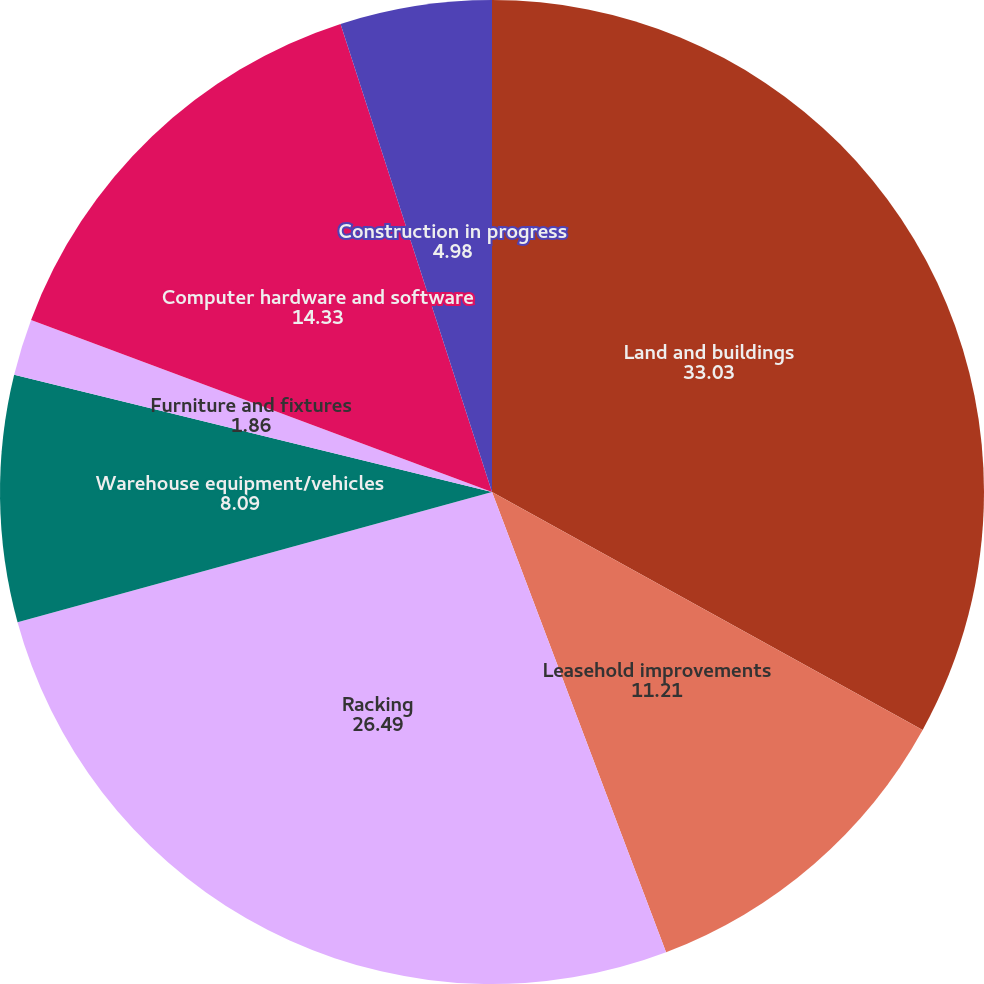Convert chart to OTSL. <chart><loc_0><loc_0><loc_500><loc_500><pie_chart><fcel>Land and buildings<fcel>Leasehold improvements<fcel>Racking<fcel>Warehouse equipment/vehicles<fcel>Furniture and fixtures<fcel>Computer hardware and software<fcel>Construction in progress<nl><fcel>33.03%<fcel>11.21%<fcel>26.49%<fcel>8.09%<fcel>1.86%<fcel>14.33%<fcel>4.98%<nl></chart> 